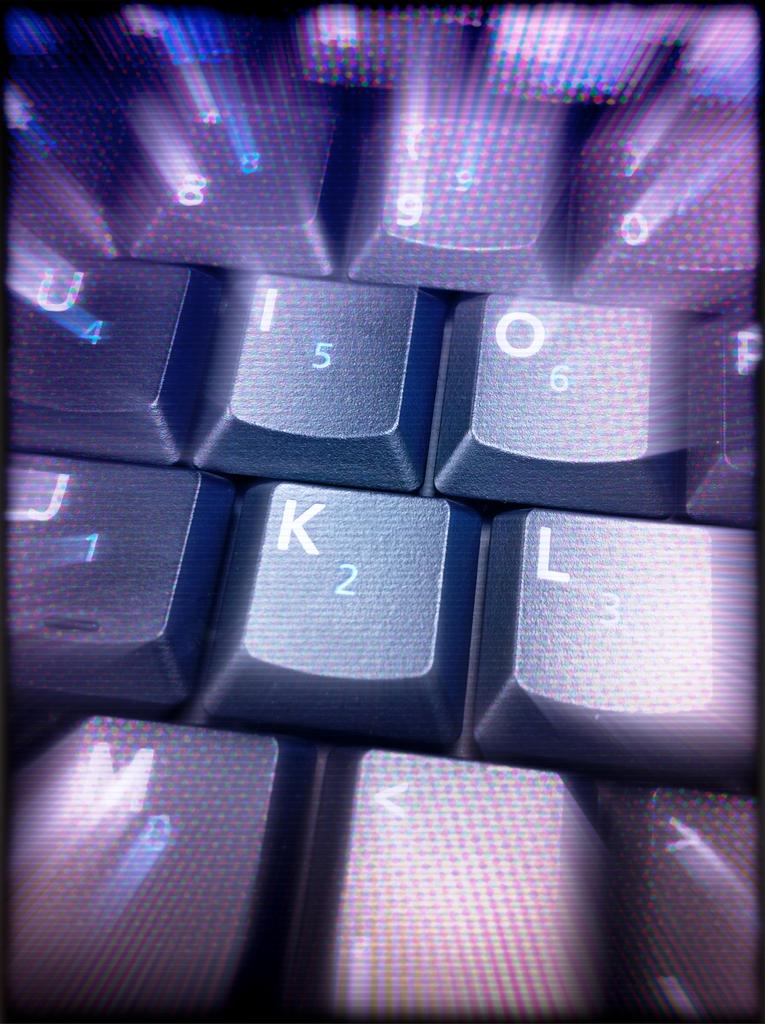What can be observed about the image in terms of its appearance? The image is edited. What type of object is featured in the image? There are key buttons in the image. What information is displayed on the key buttons? The key buttons have letters and numbers. Can you hear the song being played by the arm in the image? There is no arm or song present in the image; it features key buttons with letters and numbers. 